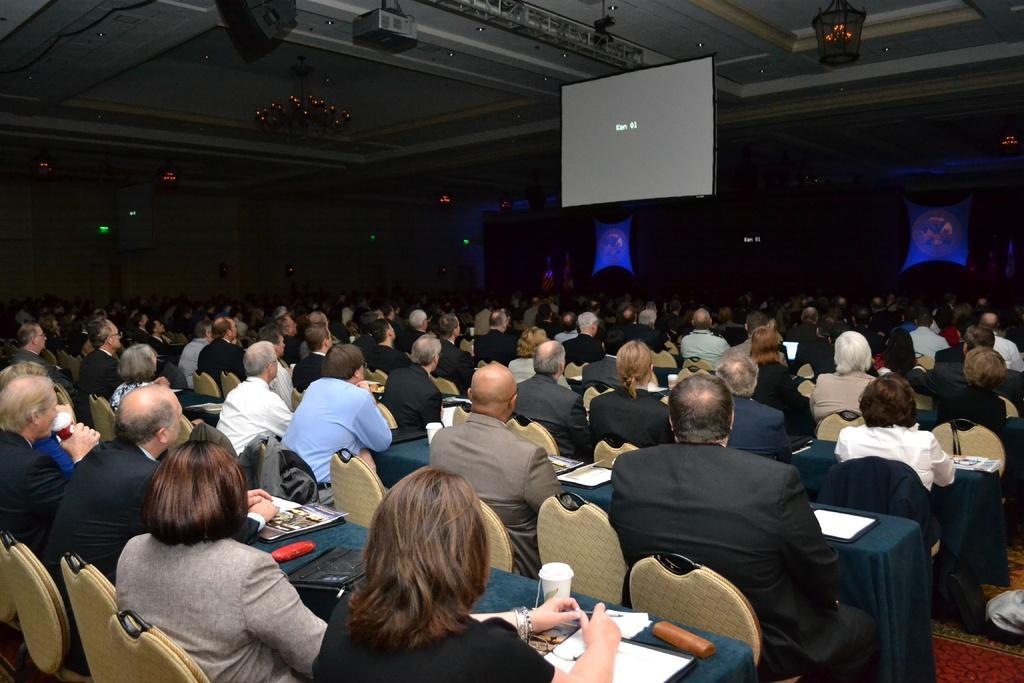Describe this image in one or two sentences. In this picture I can see group of people sitting on the chairs, there are books and some other objects on the tables, there is a projector, projector screen, there is a chandelier, there are lamps and some other objects. 